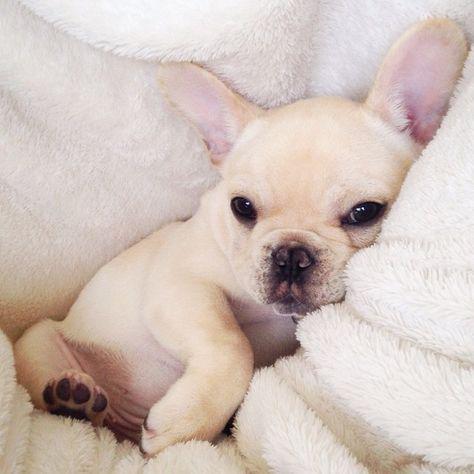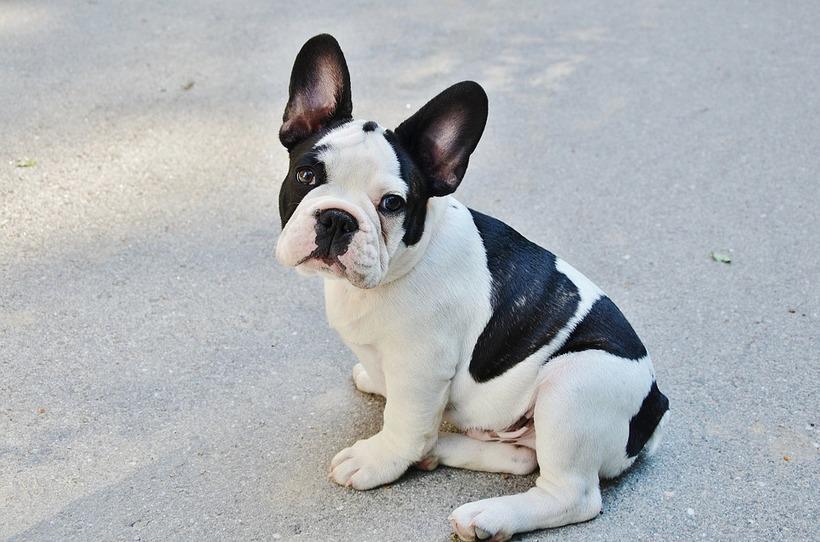The first image is the image on the left, the second image is the image on the right. Examine the images to the left and right. Is the description "There are two puppies in the right image." accurate? Answer yes or no. No. 